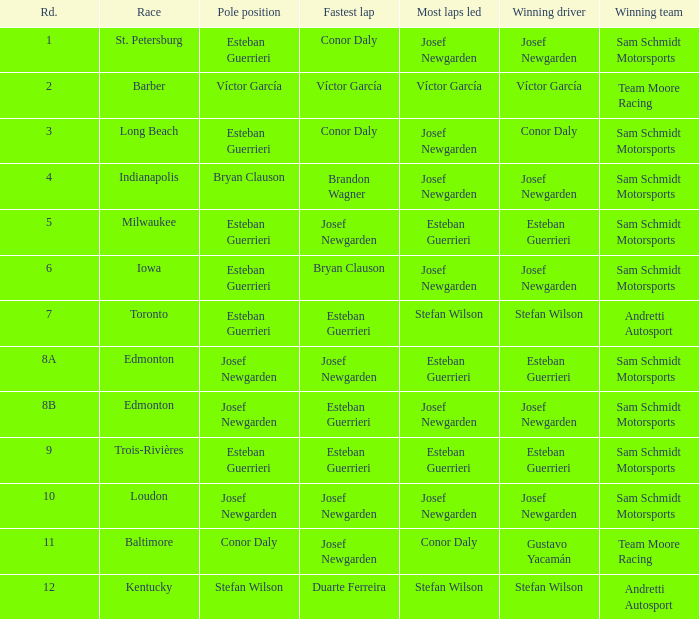Who had the pole(s) when esteban guerrieri led the most laps round 8a and josef newgarden had the fastest lap? Josef Newgarden. 